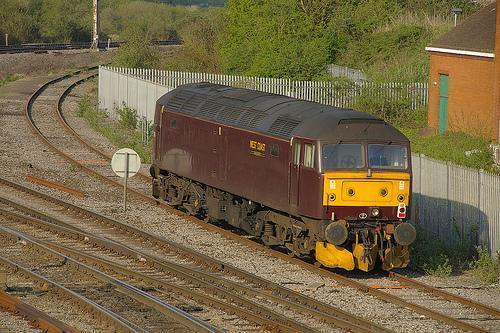How many signs are there?
Give a very brief answer. 1. How many trains?
Give a very brief answer. 1. How many windows are on the front of the train engine?
Give a very brief answer. 2. How many train engines are on the tracks?
Give a very brief answer. 1. How many trains are in this picture?
Give a very brief answer. 1. How many sets of tracks are in the picture?
Give a very brief answer. 4. How many people are in this picture?
Give a very brief answer. 0. 